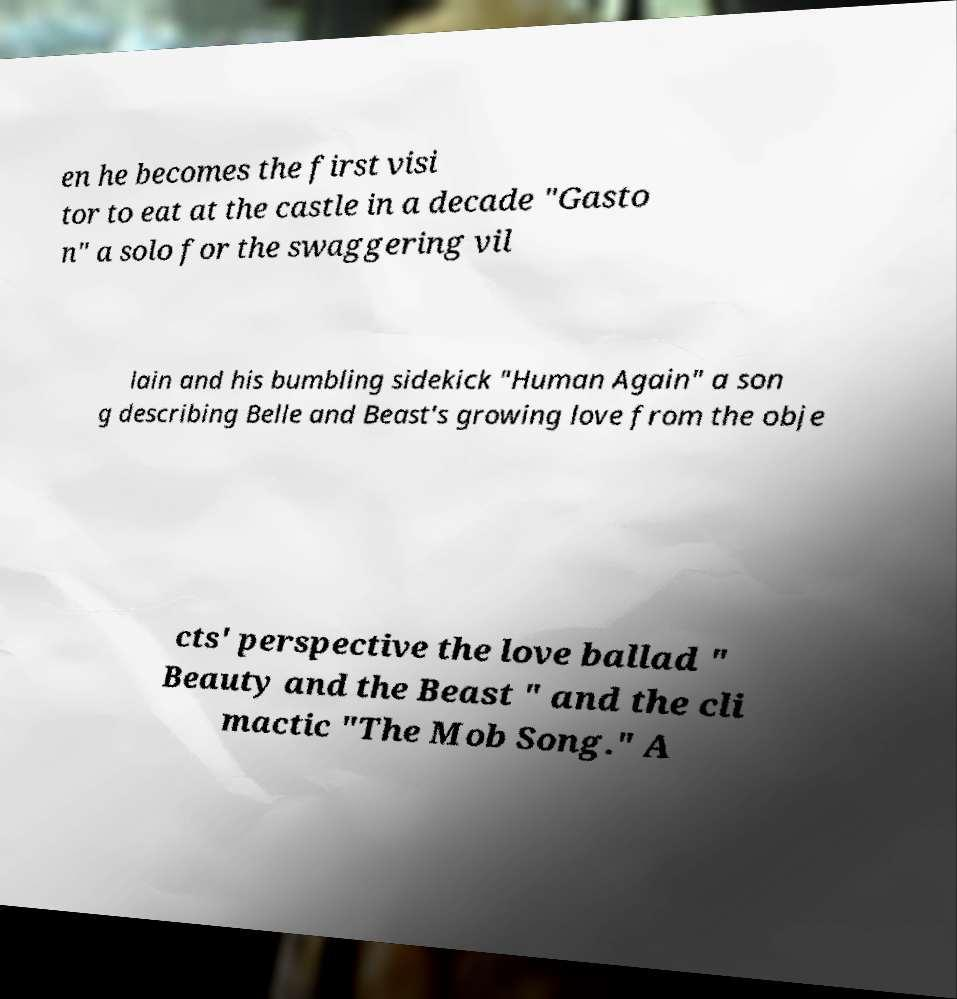For documentation purposes, I need the text within this image transcribed. Could you provide that? en he becomes the first visi tor to eat at the castle in a decade "Gasto n" a solo for the swaggering vil lain and his bumbling sidekick "Human Again" a son g describing Belle and Beast's growing love from the obje cts' perspective the love ballad " Beauty and the Beast " and the cli mactic "The Mob Song." A 